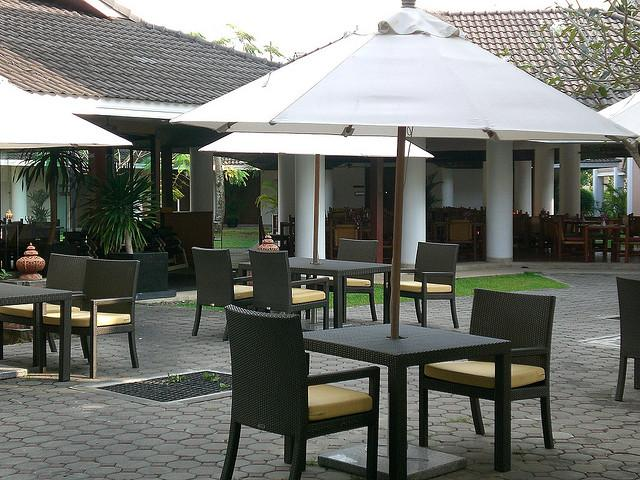What is the purpose of the umbrellas? shade 